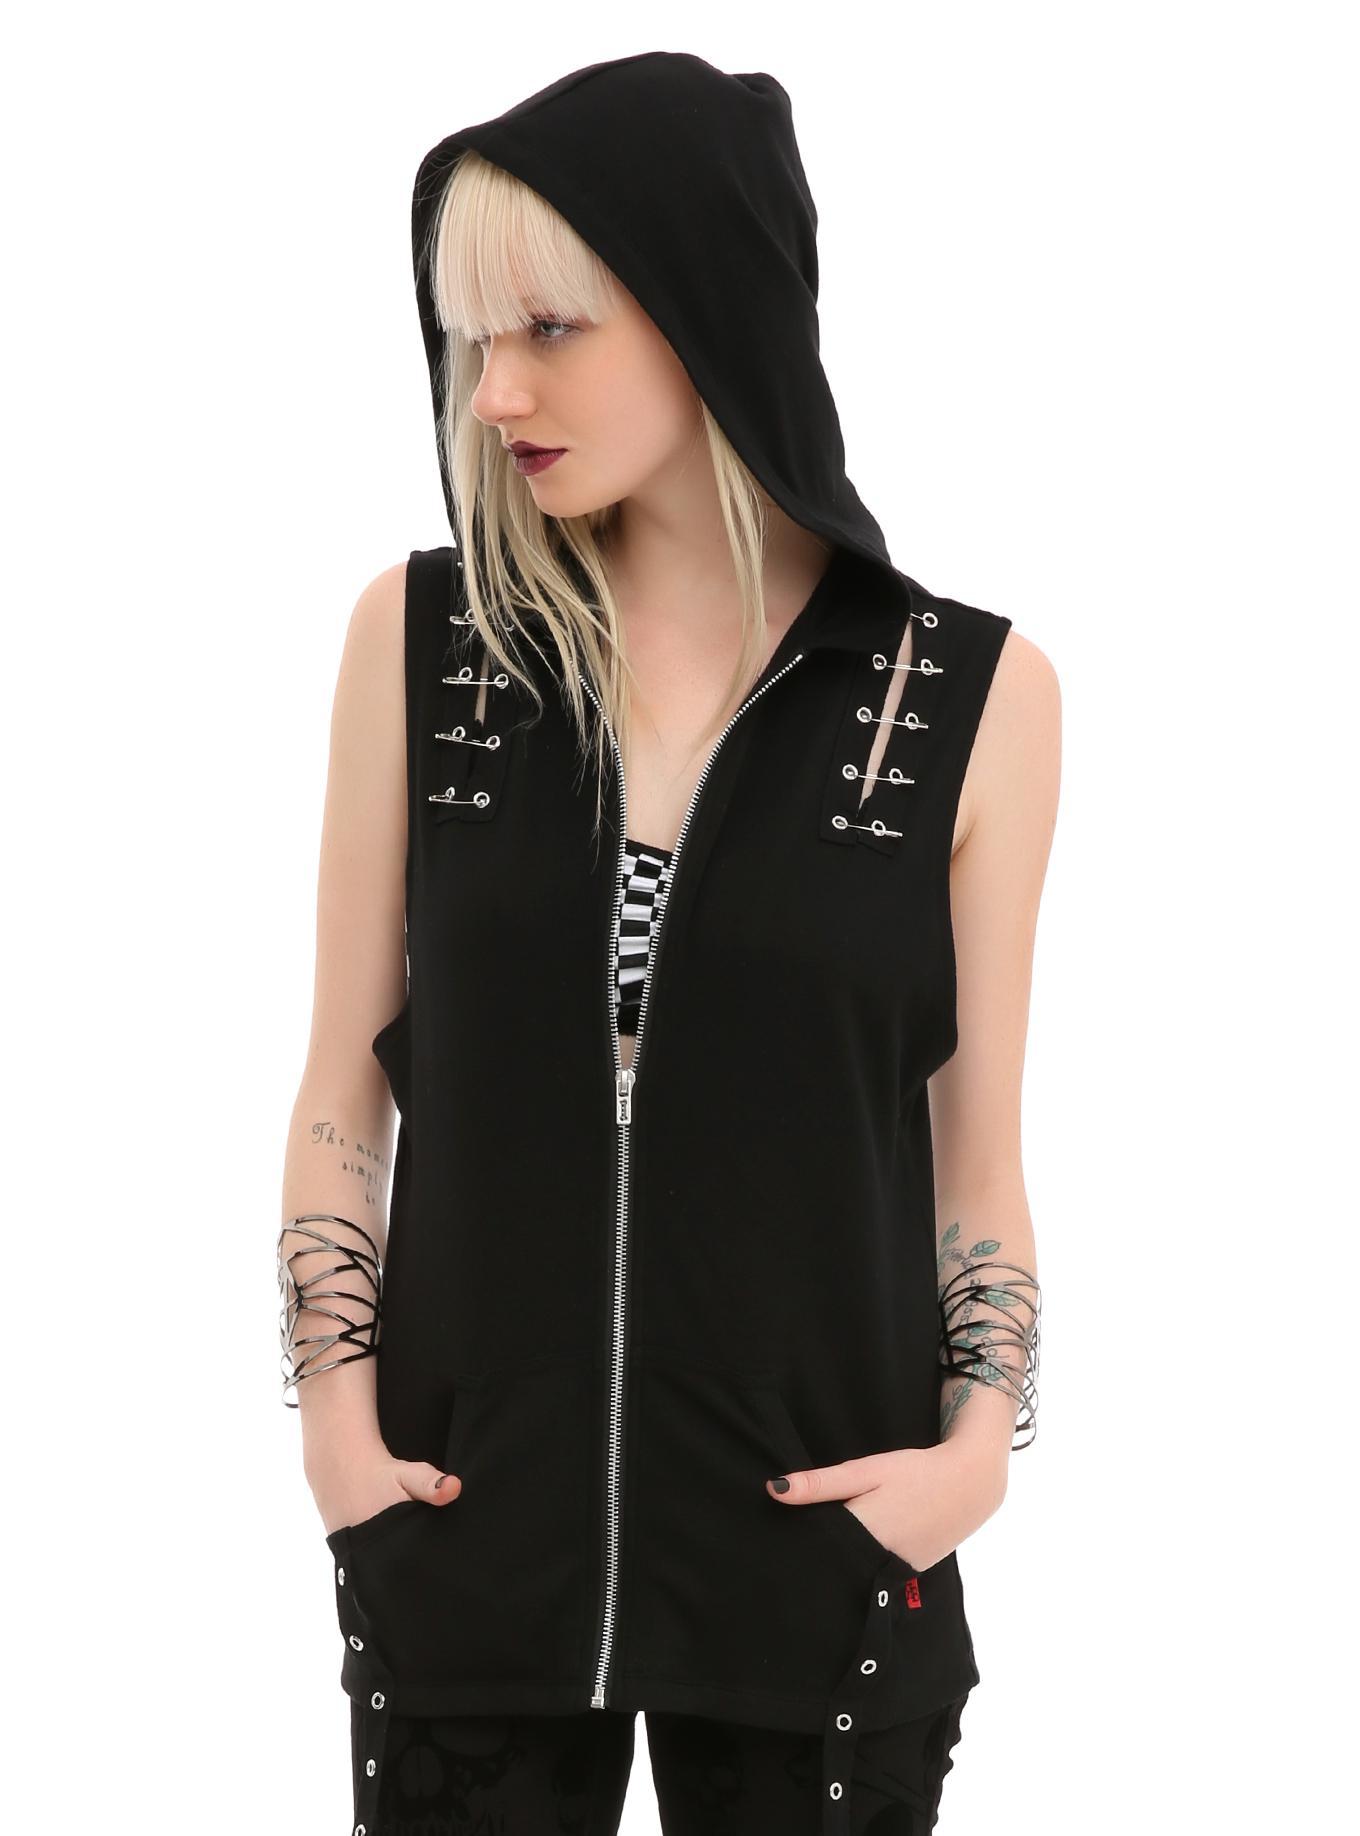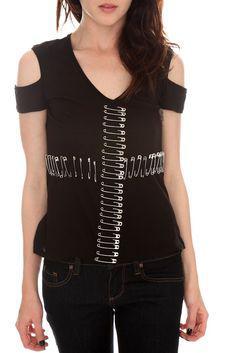The first image is the image on the left, the second image is the image on the right. Evaluate the accuracy of this statement regarding the images: "An image shows a model wearing a sleeveless black top embellished with safety pins spanning tears in the fabric.". Is it true? Answer yes or no. Yes. The first image is the image on the left, the second image is the image on the right. Analyze the images presented: Is the assertion "A woman in the image on the right is wearing a necklace." valid? Answer yes or no. No. 